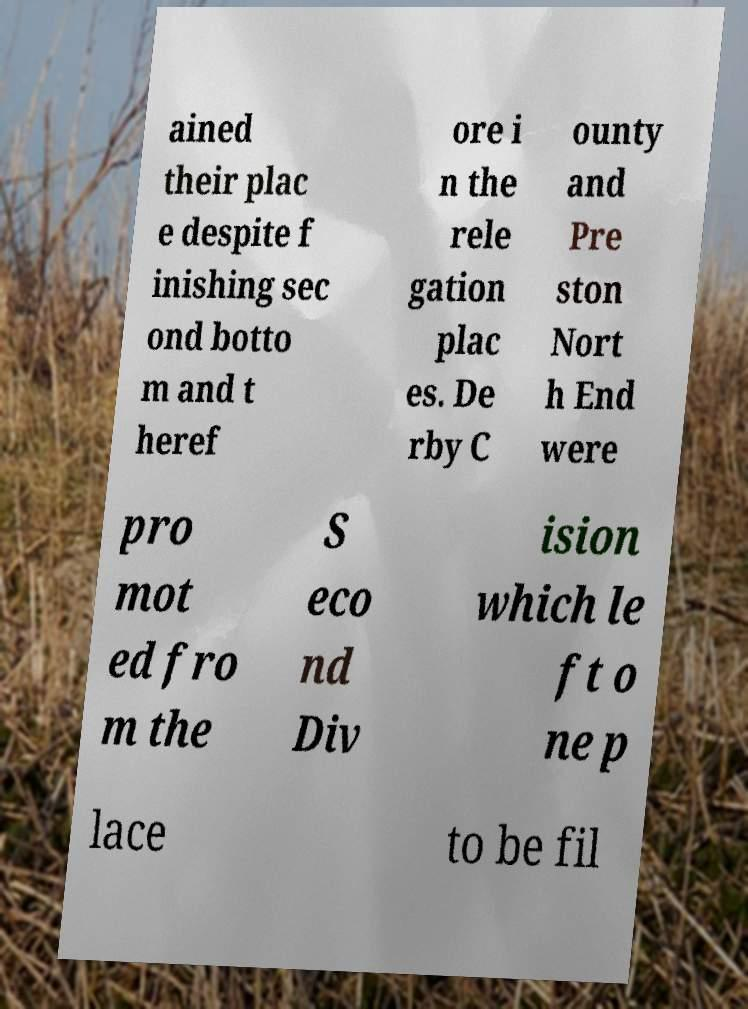Please read and relay the text visible in this image. What does it say? ained their plac e despite f inishing sec ond botto m and t heref ore i n the rele gation plac es. De rby C ounty and Pre ston Nort h End were pro mot ed fro m the S eco nd Div ision which le ft o ne p lace to be fil 